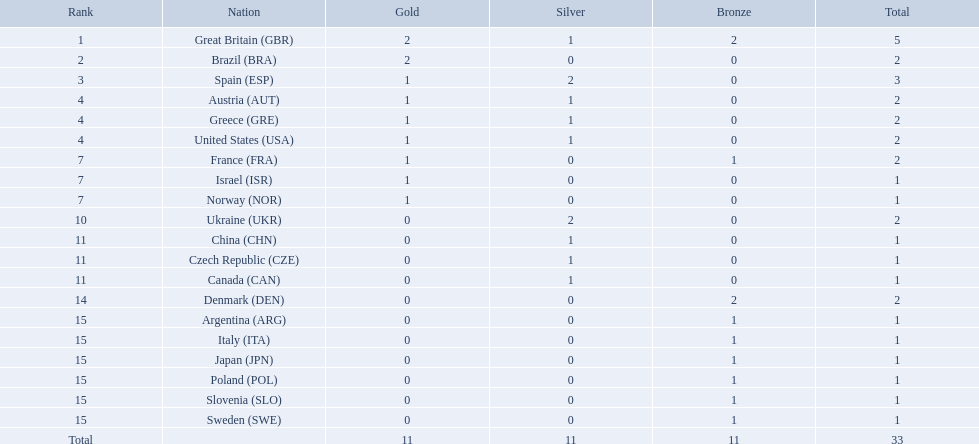Which nation received 2 silver medals? Spain (ESP), Ukraine (UKR). Of those, which nation also had 2 total medals? Spain (ESP). How many medals did spain gain 3. Only country that got more medals? Spain (ESP). What is the number of medals awarded to every nation? 5, 2, 3, 2, 2, 2, 2, 1, 1, 2, 1, 1, 1, 2, 1, 1, 1, 1, 1, 1. Which nation got 3 medals? Spain (ESP). Parse the table in full. {'header': ['Rank', 'Nation', 'Gold', 'Silver', 'Bronze', 'Total'], 'rows': [['1', 'Great Britain\xa0(GBR)', '2', '1', '2', '5'], ['2', 'Brazil\xa0(BRA)', '2', '0', '0', '2'], ['3', 'Spain\xa0(ESP)', '1', '2', '0', '3'], ['4', 'Austria\xa0(AUT)', '1', '1', '0', '2'], ['4', 'Greece\xa0(GRE)', '1', '1', '0', '2'], ['4', 'United States\xa0(USA)', '1', '1', '0', '2'], ['7', 'France\xa0(FRA)', '1', '0', '1', '2'], ['7', 'Israel\xa0(ISR)', '1', '0', '0', '1'], ['7', 'Norway\xa0(NOR)', '1', '0', '0', '1'], ['10', 'Ukraine\xa0(UKR)', '0', '2', '0', '2'], ['11', 'China\xa0(CHN)', '0', '1', '0', '1'], ['11', 'Czech Republic\xa0(CZE)', '0', '1', '0', '1'], ['11', 'Canada\xa0(CAN)', '0', '1', '0', '1'], ['14', 'Denmark\xa0(DEN)', '0', '0', '2', '2'], ['15', 'Argentina\xa0(ARG)', '0', '0', '1', '1'], ['15', 'Italy\xa0(ITA)', '0', '0', '1', '1'], ['15', 'Japan\xa0(JPN)', '0', '0', '1', '1'], ['15', 'Poland\xa0(POL)', '0', '0', '1', '1'], ['15', 'Slovenia\xa0(SLO)', '0', '0', '1', '1'], ['15', 'Sweden\xa0(SWE)', '0', '0', '1', '1'], ['Total', '', '11', '11', '11', '33']]} For each nation, what was the medal count? 5, 2, 3, 2, 2, 2, 2, 1, 1, 2, 1, 1, 1, 2, 1, 1, 1, 1, 1, 1. Which nation secured 3 medals? Spain (ESP). What is the complete list of countries? Great Britain (GBR), Brazil (BRA), Spain (ESP), Austria (AUT), Greece (GRE), United States (USA), France (FRA), Israel (ISR), Norway (NOR), Ukraine (UKR), China (CHN), Czech Republic (CZE), Canada (CAN), Denmark (DEN), Argentina (ARG), Italy (ITA), Japan (JPN), Poland (POL), Slovenia (SLO), Sweden (SWE). Which countries managed to receive a medal? Great Britain (GBR), Brazil (BRA), Spain (ESP), Austria (AUT), Greece (GRE), United States (USA), France (FRA), Israel (ISR), Norway (NOR), Ukraine (UKR), China (CHN), Czech Republic (CZE), Canada (CAN), Denmark (DEN), Argentina (ARG), Italy (ITA), Japan (JPN), Poland (POL), Slovenia (SLO), Sweden (SWE). Which nations obtained a minimum of three medals? Great Britain (GBR), Spain (ESP). Which specific country secured three medals? Spain (ESP). Can you list all the countries? Great Britain (GBR), Brazil (BRA), Spain (ESP), Austria (AUT), Greece (GRE), United States (USA), France (FRA), Israel (ISR), Norway (NOR), Ukraine (UKR), China (CHN), Czech Republic (CZE), Canada (CAN), Denmark (DEN), Argentina (ARG), Italy (ITA), Japan (JPN), Poland (POL), Slovenia (SLO), Sweden (SWE). Which of these countries were awarded a medal? Great Britain (GBR), Brazil (BRA), Spain (ESP), Austria (AUT), Greece (GRE), United States (USA), France (FRA), Israel (ISR), Norway (NOR), Ukraine (UKR), China (CHN), Czech Republic (CZE), Canada (CAN), Denmark (DEN), Argentina (ARG), Italy (ITA), Japan (JPN), Poland (POL), Slovenia (SLO), Sweden (SWE). Which countries achieved three or more medals? Great Britain (GBR), Spain (ESP). Which country accomplished exactly three medals? Spain (ESP). Can you name all the countries? Great Britain (GBR), Brazil (BRA), Spain (ESP), Austria (AUT), Greece (GRE), United States (USA), France (FRA), Israel (ISR), Norway (NOR), Ukraine (UKR), China (CHN), Czech Republic (CZE), Canada (CAN), Denmark (DEN), Argentina (ARG), Italy (ITA), Japan (JPN), Poland (POL), Slovenia (SLO), Sweden (SWE). Which countries gained a medal in the competition? Great Britain (GBR), Brazil (BRA), Spain (ESP), Austria (AUT), Greece (GRE), United States (USA), France (FRA), Israel (ISR), Norway (NOR), Ukraine (UKR), China (CHN), Czech Republic (CZE), Canada (CAN), Denmark (DEN), Argentina (ARG), Italy (ITA), Japan (JPN), Poland (POL), Slovenia (SLO), Sweden (SWE). Which countries earned no less than three medals? Great Britain (GBR), Spain (ESP). Which country acquired three medals in total? Spain (ESP). 